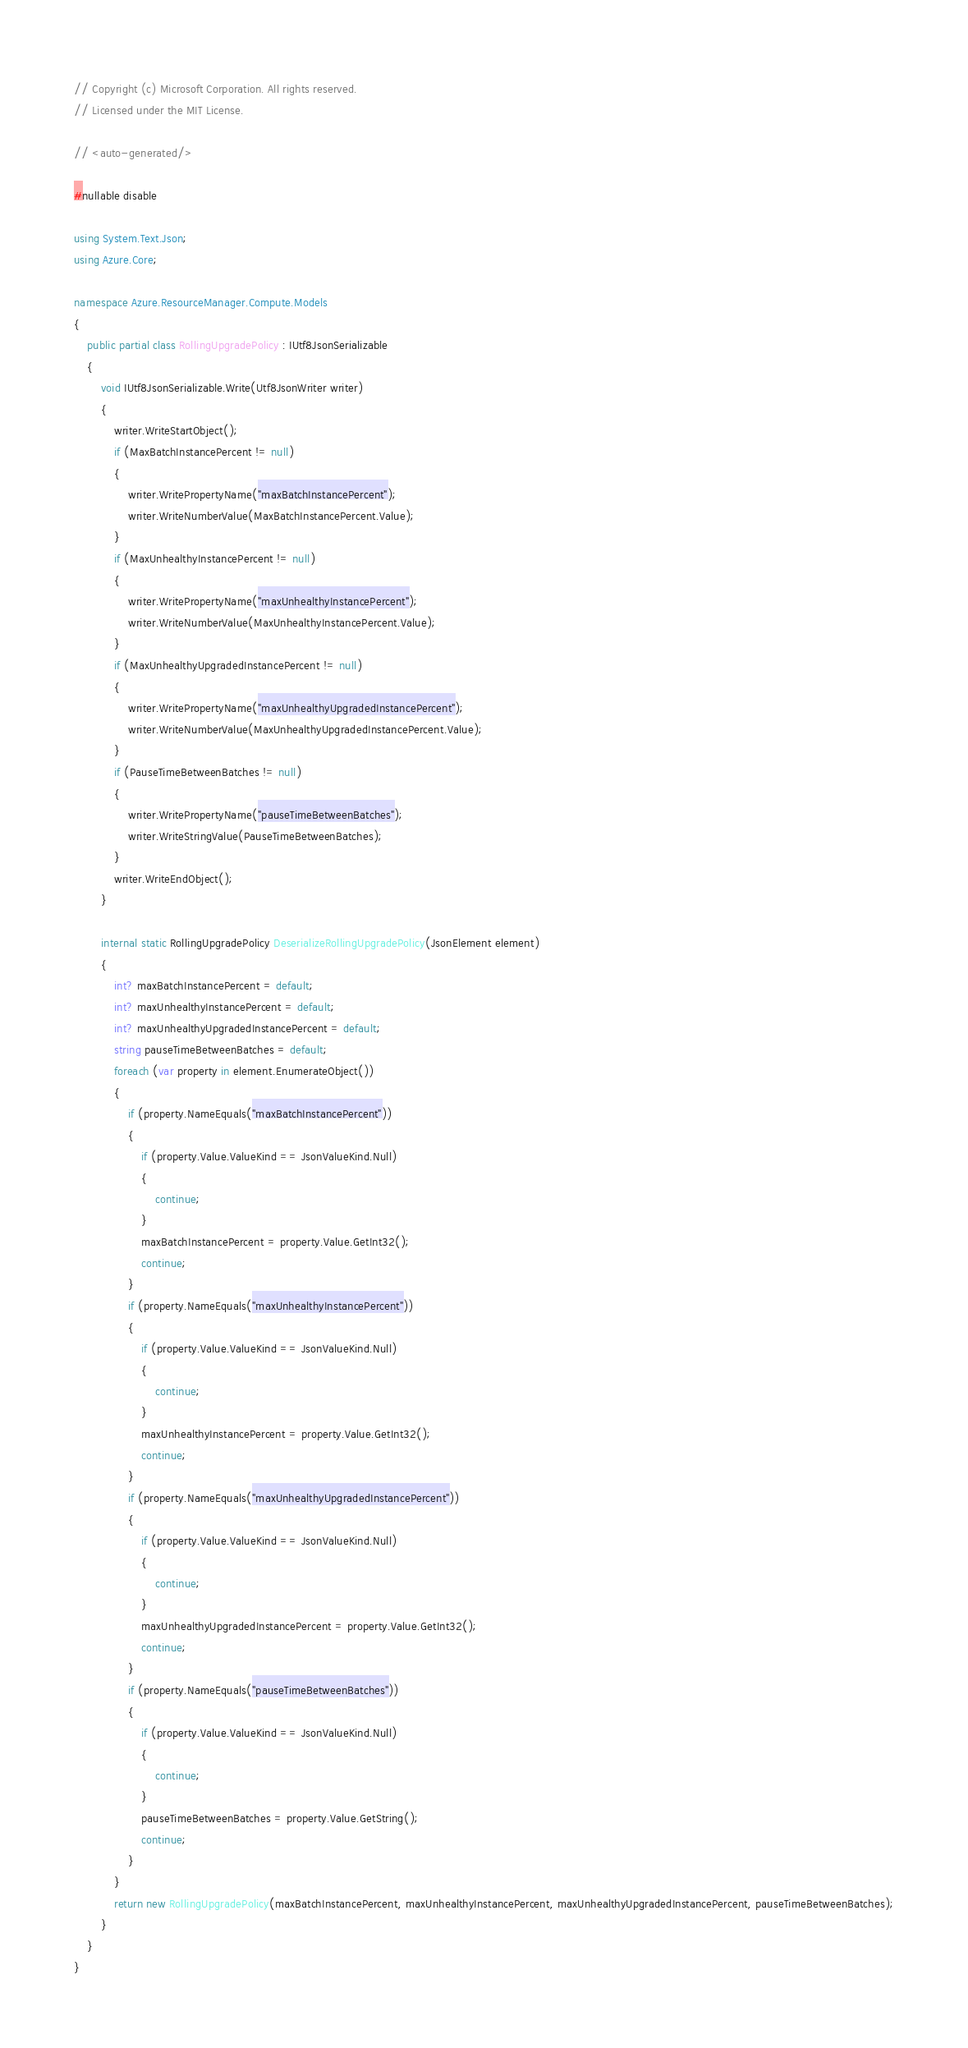Convert code to text. <code><loc_0><loc_0><loc_500><loc_500><_C#_>// Copyright (c) Microsoft Corporation. All rights reserved.
// Licensed under the MIT License.

// <auto-generated/>

#nullable disable

using System.Text.Json;
using Azure.Core;

namespace Azure.ResourceManager.Compute.Models
{
    public partial class RollingUpgradePolicy : IUtf8JsonSerializable
    {
        void IUtf8JsonSerializable.Write(Utf8JsonWriter writer)
        {
            writer.WriteStartObject();
            if (MaxBatchInstancePercent != null)
            {
                writer.WritePropertyName("maxBatchInstancePercent");
                writer.WriteNumberValue(MaxBatchInstancePercent.Value);
            }
            if (MaxUnhealthyInstancePercent != null)
            {
                writer.WritePropertyName("maxUnhealthyInstancePercent");
                writer.WriteNumberValue(MaxUnhealthyInstancePercent.Value);
            }
            if (MaxUnhealthyUpgradedInstancePercent != null)
            {
                writer.WritePropertyName("maxUnhealthyUpgradedInstancePercent");
                writer.WriteNumberValue(MaxUnhealthyUpgradedInstancePercent.Value);
            }
            if (PauseTimeBetweenBatches != null)
            {
                writer.WritePropertyName("pauseTimeBetweenBatches");
                writer.WriteStringValue(PauseTimeBetweenBatches);
            }
            writer.WriteEndObject();
        }

        internal static RollingUpgradePolicy DeserializeRollingUpgradePolicy(JsonElement element)
        {
            int? maxBatchInstancePercent = default;
            int? maxUnhealthyInstancePercent = default;
            int? maxUnhealthyUpgradedInstancePercent = default;
            string pauseTimeBetweenBatches = default;
            foreach (var property in element.EnumerateObject())
            {
                if (property.NameEquals("maxBatchInstancePercent"))
                {
                    if (property.Value.ValueKind == JsonValueKind.Null)
                    {
                        continue;
                    }
                    maxBatchInstancePercent = property.Value.GetInt32();
                    continue;
                }
                if (property.NameEquals("maxUnhealthyInstancePercent"))
                {
                    if (property.Value.ValueKind == JsonValueKind.Null)
                    {
                        continue;
                    }
                    maxUnhealthyInstancePercent = property.Value.GetInt32();
                    continue;
                }
                if (property.NameEquals("maxUnhealthyUpgradedInstancePercent"))
                {
                    if (property.Value.ValueKind == JsonValueKind.Null)
                    {
                        continue;
                    }
                    maxUnhealthyUpgradedInstancePercent = property.Value.GetInt32();
                    continue;
                }
                if (property.NameEquals("pauseTimeBetweenBatches"))
                {
                    if (property.Value.ValueKind == JsonValueKind.Null)
                    {
                        continue;
                    }
                    pauseTimeBetweenBatches = property.Value.GetString();
                    continue;
                }
            }
            return new RollingUpgradePolicy(maxBatchInstancePercent, maxUnhealthyInstancePercent, maxUnhealthyUpgradedInstancePercent, pauseTimeBetweenBatches);
        }
    }
}
</code> 